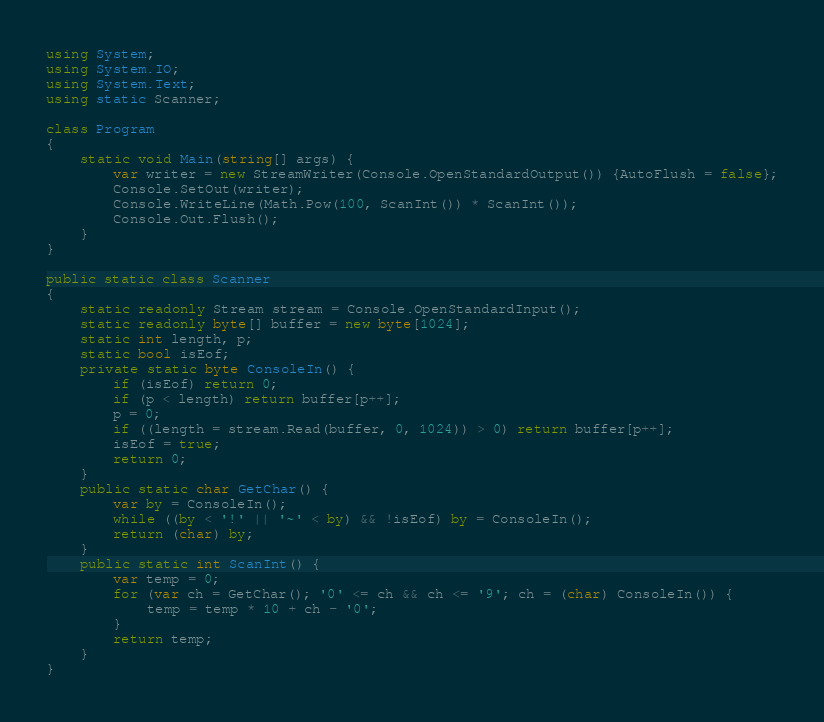<code> <loc_0><loc_0><loc_500><loc_500><_C#_>using System;
using System.IO;
using System.Text;
using static Scanner;

class Program
{
    static void Main(string[] args) {
        var writer = new StreamWriter(Console.OpenStandardOutput()) {AutoFlush = false};
        Console.SetOut(writer);
        Console.WriteLine(Math.Pow(100, ScanInt()) * ScanInt());
        Console.Out.Flush();
    }
}

public static class Scanner
{
    static readonly Stream stream = Console.OpenStandardInput();
    static readonly byte[] buffer = new byte[1024];
    static int length, p;
    static bool isEof;
    private static byte ConsoleIn() {
        if (isEof) return 0;
        if (p < length) return buffer[p++];
        p = 0;
        if ((length = stream.Read(buffer, 0, 1024)) > 0) return buffer[p++];
        isEof = true;
        return 0;
    }
    public static char GetChar() {
        var by = ConsoleIn();
        while ((by < '!' || '~' < by) && !isEof) by = ConsoleIn();
        return (char) by;
    }
    public static int ScanInt() {
        var temp = 0;
        for (var ch = GetChar(); '0' <= ch && ch <= '9'; ch = (char) ConsoleIn()) {
            temp = temp * 10 + ch - '0';
        }
        return temp;
    }
}</code> 